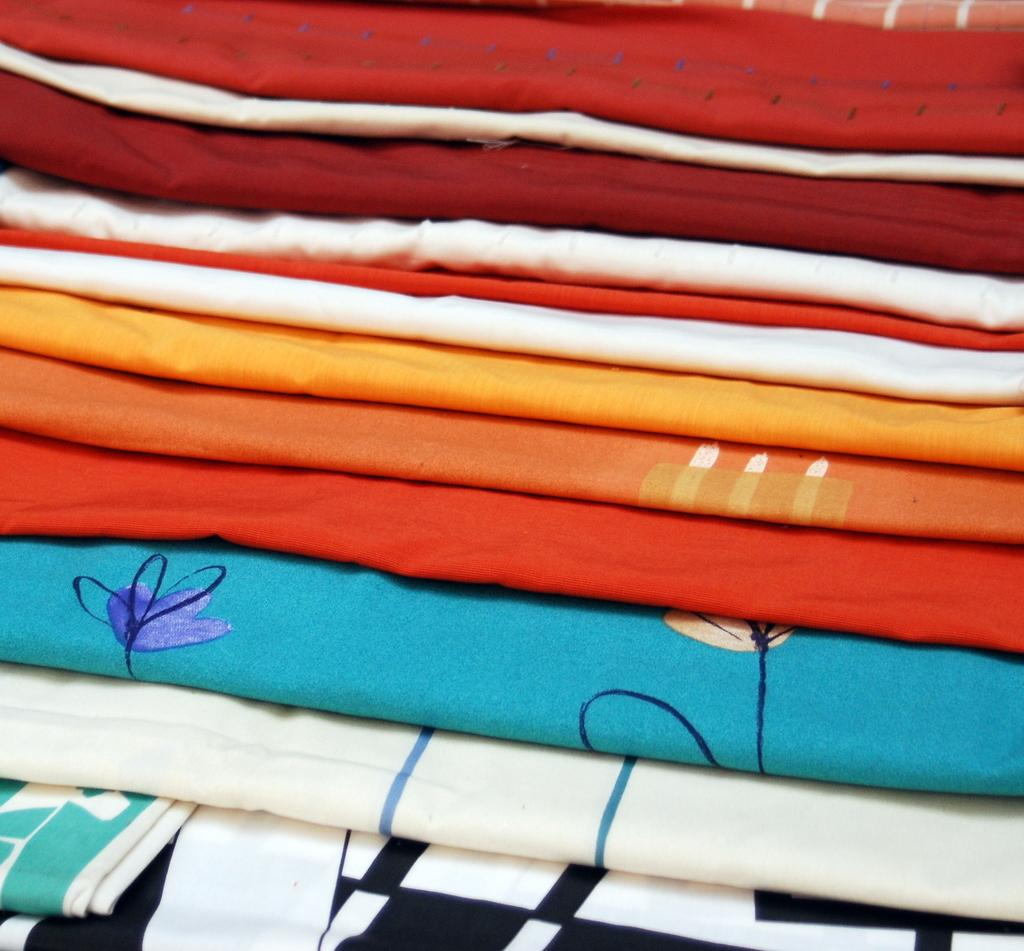What type of bedding is featured in the image? There are colorful bed sheets in the image. What colors can be seen on the bed sheets? The bed sheets have blue, orange, red, and white colors. Where are the bed sheets located in the image? The bed sheets are in the middle of the image. What type of songs can be heard being sung by the bed sheets in the image? There are no songs being sung by the bed sheets in the image, as bed sheets are inanimate objects and cannot sing. 